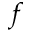Convert formula to latex. <formula><loc_0><loc_0><loc_500><loc_500>f</formula> 